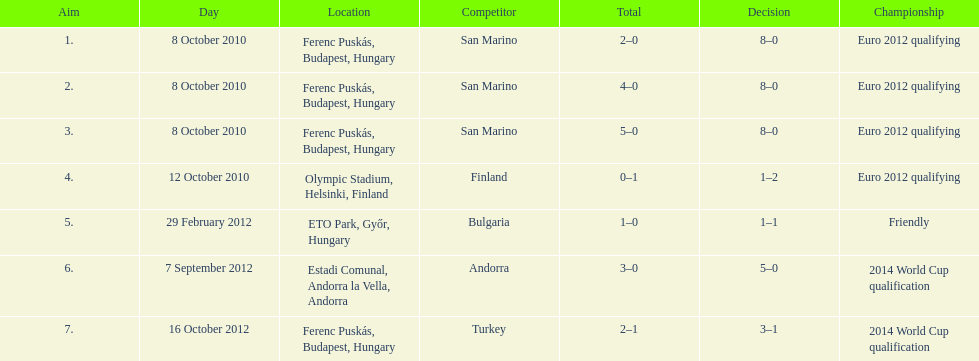Szalai scored only one more international goal against all other countries put together than he did against what one country? San Marino. 